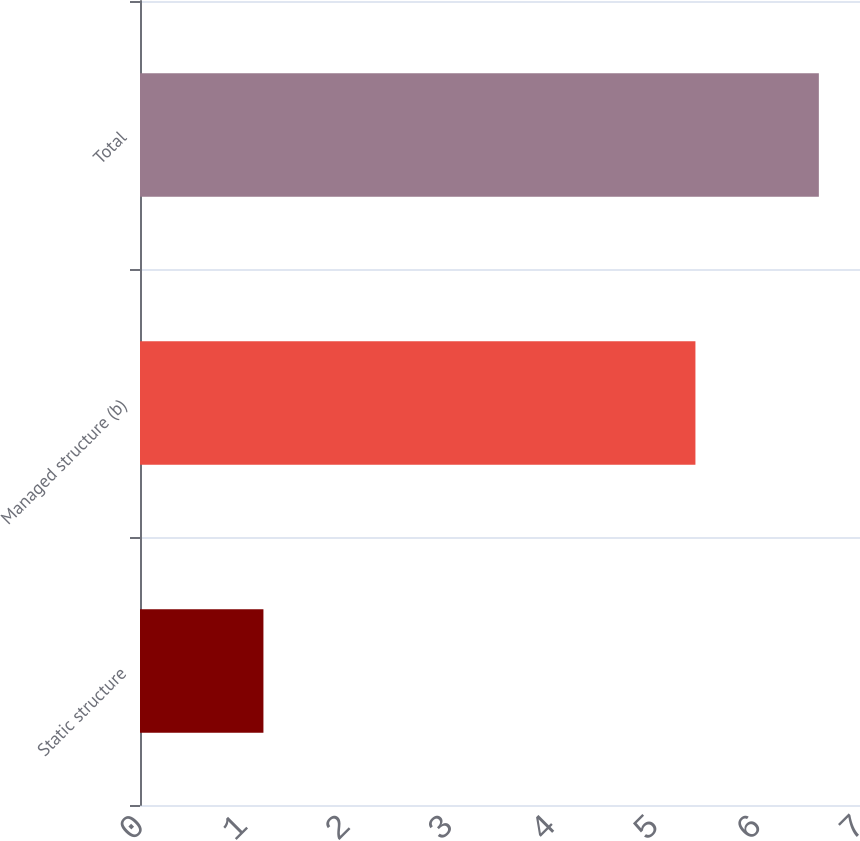Convert chart. <chart><loc_0><loc_0><loc_500><loc_500><bar_chart><fcel>Static structure<fcel>Managed structure (b)<fcel>Total<nl><fcel>1.2<fcel>5.4<fcel>6.6<nl></chart> 